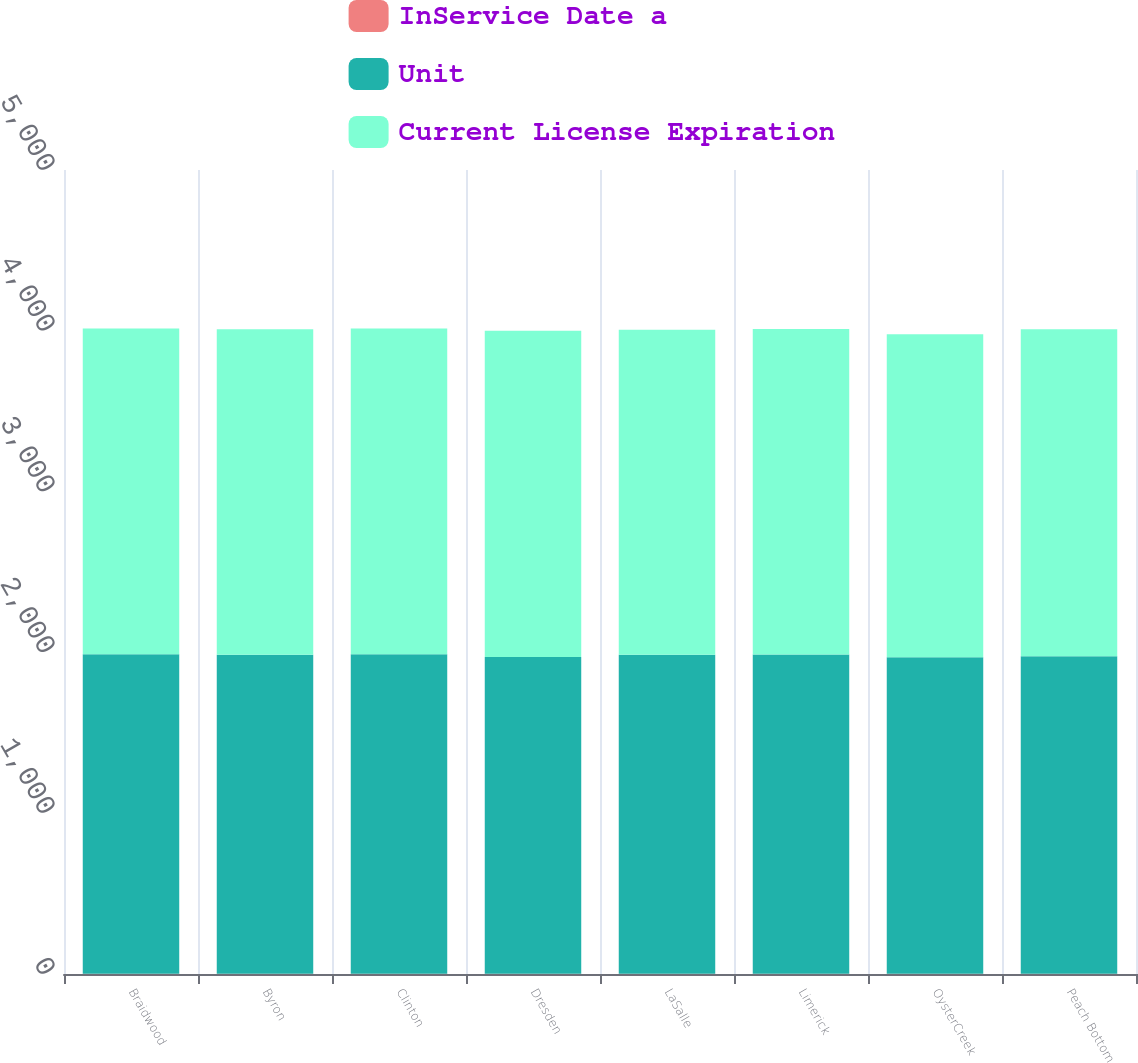Convert chart to OTSL. <chart><loc_0><loc_0><loc_500><loc_500><stacked_bar_chart><ecel><fcel>Braidwood<fcel>Byron<fcel>Clinton<fcel>Dresden<fcel>LaSalle<fcel>Limerick<fcel>OysterCreek<fcel>Peach Bottom<nl><fcel>InService Date a<fcel>1<fcel>1<fcel>1<fcel>2<fcel>1<fcel>1<fcel>1<fcel>2<nl><fcel>Unit<fcel>1988<fcel>1985<fcel>1987<fcel>1970<fcel>1984<fcel>1986<fcel>1969<fcel>1974<nl><fcel>Current License Expiration<fcel>2026<fcel>2024<fcel>2026<fcel>2029<fcel>2022<fcel>2024<fcel>2009<fcel>2033<nl></chart> 